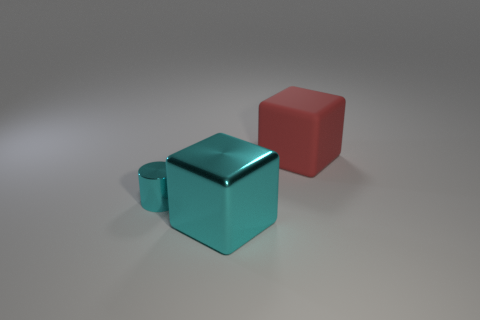Add 3 cyan cylinders. How many objects exist? 6 Subtract all cylinders. How many objects are left? 2 Add 2 large cyan shiny cubes. How many large cyan shiny cubes are left? 3 Add 1 big matte objects. How many big matte objects exist? 2 Subtract 0 brown blocks. How many objects are left? 3 Subtract all metallic cylinders. Subtract all large blocks. How many objects are left? 0 